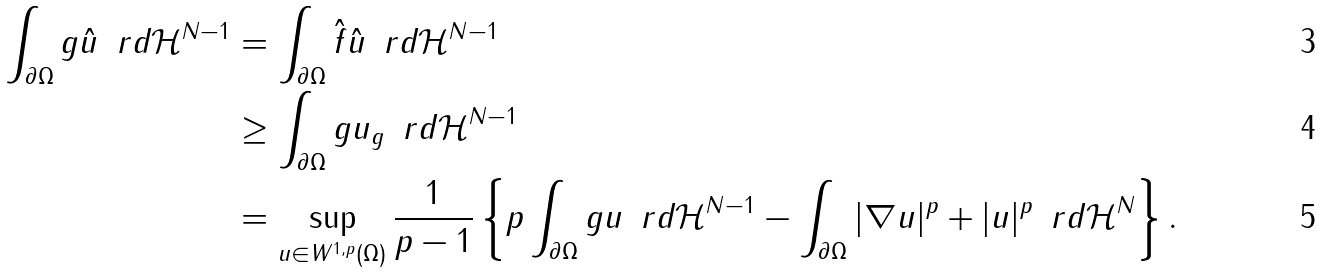<formula> <loc_0><loc_0><loc_500><loc_500>\int _ { \partial \Omega } g \hat { u } \, \ r d \mathcal { H } ^ { N - 1 } & = \int _ { \partial \Omega } \hat { f } \hat { u } \, \ r d \mathcal { H } ^ { N - 1 } \\ & \geq \int _ { \partial \Omega } g u _ { g } \, \ r d \mathcal { H } ^ { N - 1 } \\ & = \sup _ { u \in W ^ { 1 , p } ( \Omega ) } \frac { 1 } { p - 1 } \left \{ p \int _ { \partial \Omega } g u \, \ r d \mathcal { H } ^ { N - 1 } - \int _ { \partial \Omega } | \nabla u | ^ { p } + | u | ^ { p } \, \ r d \mathcal { H } ^ { N } \right \} .</formula> 